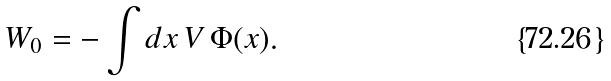Convert formula to latex. <formula><loc_0><loc_0><loc_500><loc_500>W _ { 0 } = - \int d x \, V \, \Phi ( x ) .</formula> 